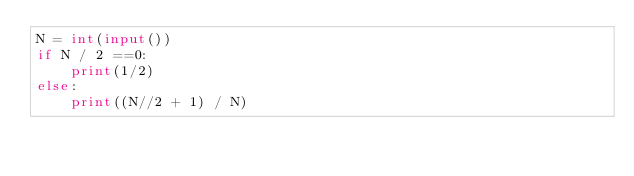Convert code to text. <code><loc_0><loc_0><loc_500><loc_500><_Python_>N = int(input())
if N / 2 ==0:
    print(1/2)
else:
    print((N//2 + 1) / N)</code> 